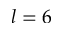<formula> <loc_0><loc_0><loc_500><loc_500>l = 6</formula> 